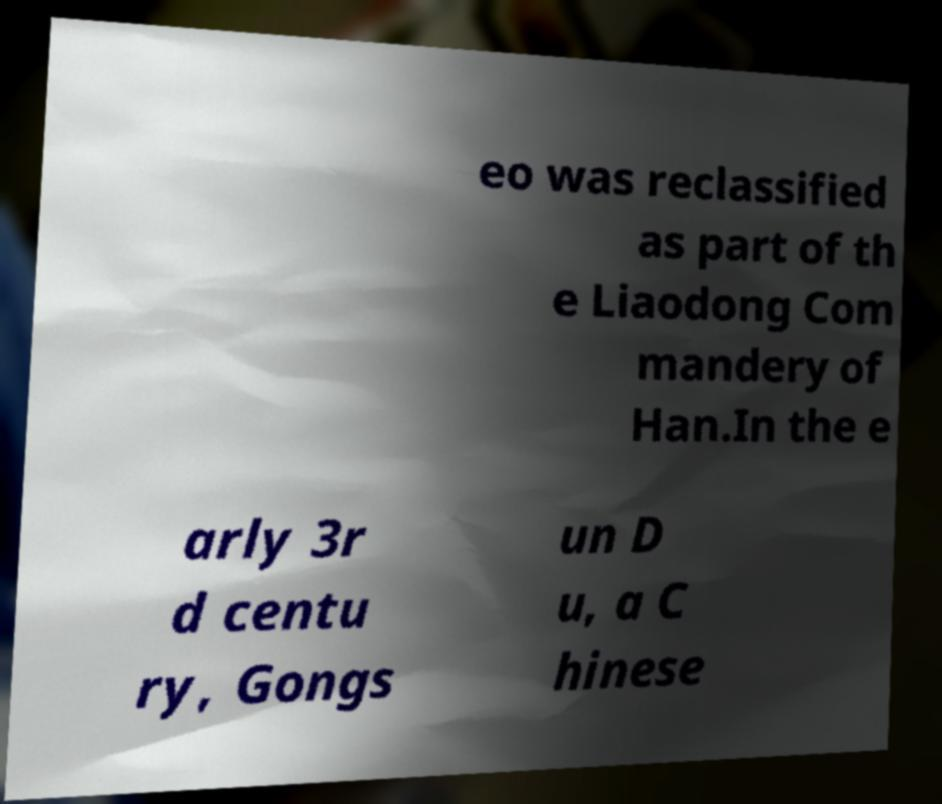I need the written content from this picture converted into text. Can you do that? eo was reclassified as part of th e Liaodong Com mandery of Han.In the e arly 3r d centu ry, Gongs un D u, a C hinese 